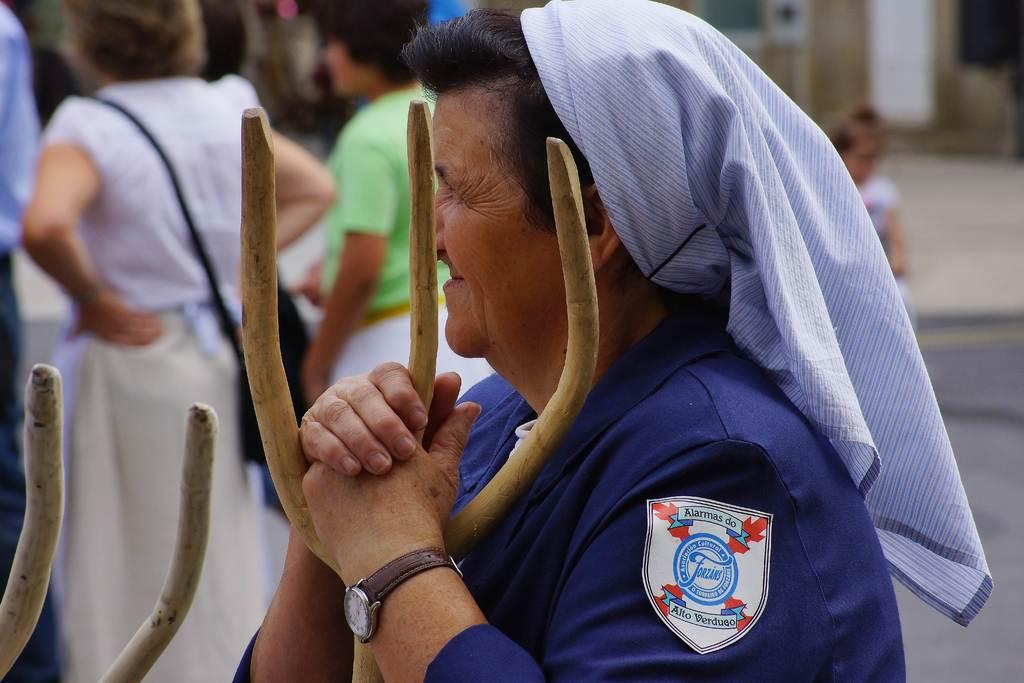Who is the main subject in the image? There is a woman in the image. What is the woman wearing on her wrist? The woman is wearing a watch. What object is the woman holding in her hand? The woman is holding a wooden stick. What can be seen in the background of the image? There is a group of people in the background of the image. How clear is the image of the group of people in the background? The image of the group of people in the background is blurry. What does the woman believe about the book she is reading in the image? There is no book present in the image, and the woman is not reading anything. 